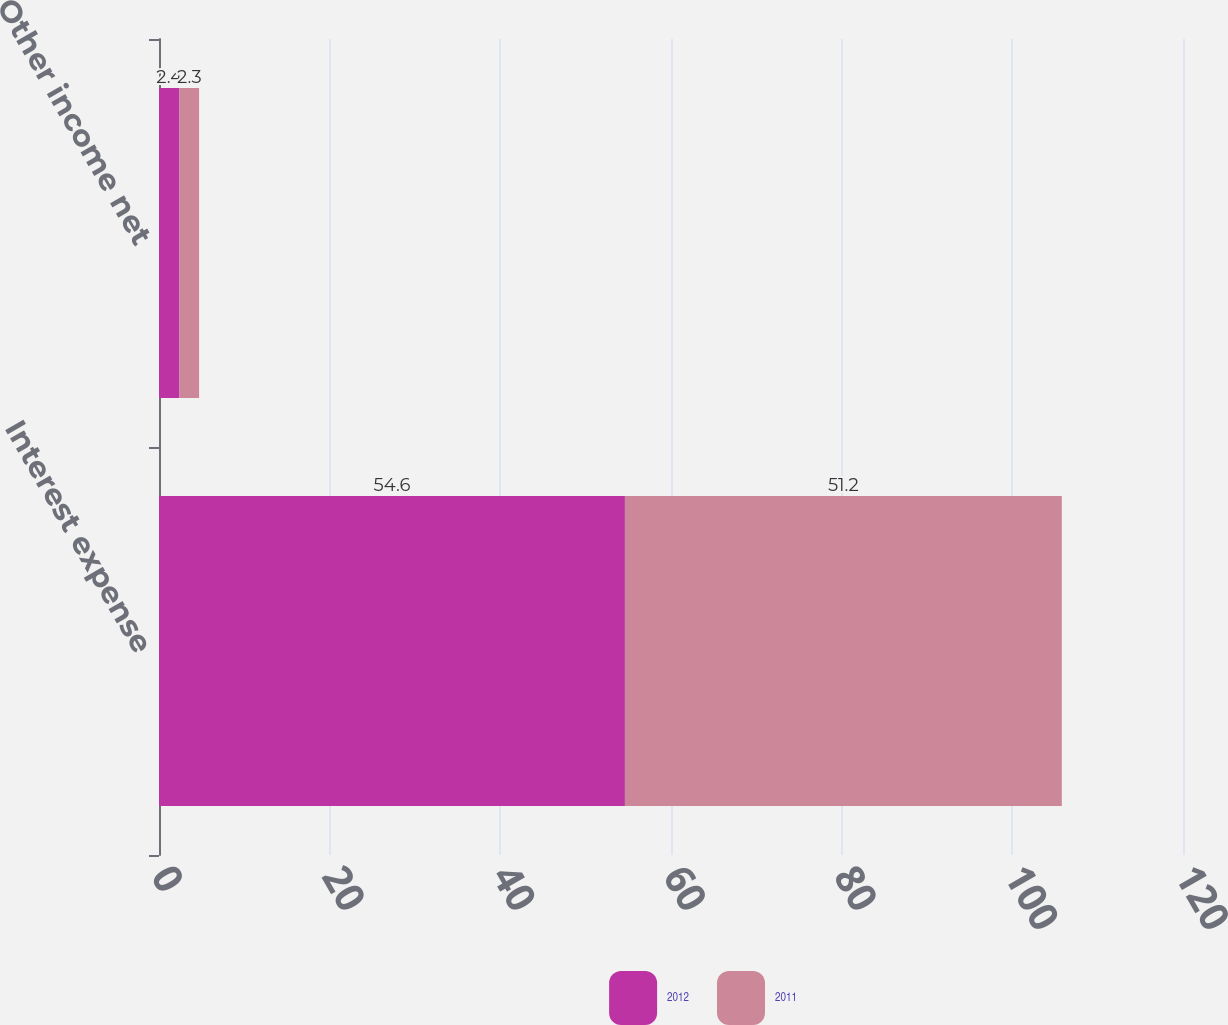<chart> <loc_0><loc_0><loc_500><loc_500><stacked_bar_chart><ecel><fcel>Interest expense<fcel>Other income net<nl><fcel>2012<fcel>54.6<fcel>2.4<nl><fcel>2011<fcel>51.2<fcel>2.3<nl></chart> 